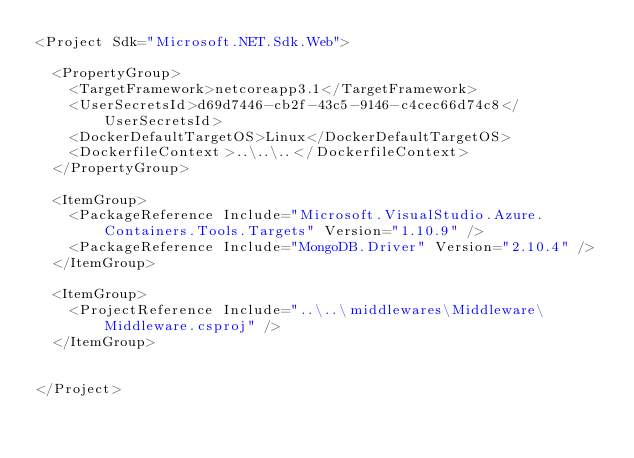Convert code to text. <code><loc_0><loc_0><loc_500><loc_500><_XML_><Project Sdk="Microsoft.NET.Sdk.Web">

  <PropertyGroup>
    <TargetFramework>netcoreapp3.1</TargetFramework>
    <UserSecretsId>d69d7446-cb2f-43c5-9146-c4cec66d74c8</UserSecretsId>
    <DockerDefaultTargetOS>Linux</DockerDefaultTargetOS>
    <DockerfileContext>..\..\..</DockerfileContext>
  </PropertyGroup>

  <ItemGroup>
    <PackageReference Include="Microsoft.VisualStudio.Azure.Containers.Tools.Targets" Version="1.10.9" />
    <PackageReference Include="MongoDB.Driver" Version="2.10.4" />
  </ItemGroup>

  <ItemGroup>
    <ProjectReference Include="..\..\middlewares\Middleware\Middleware.csproj" />
  </ItemGroup>


</Project>
</code> 